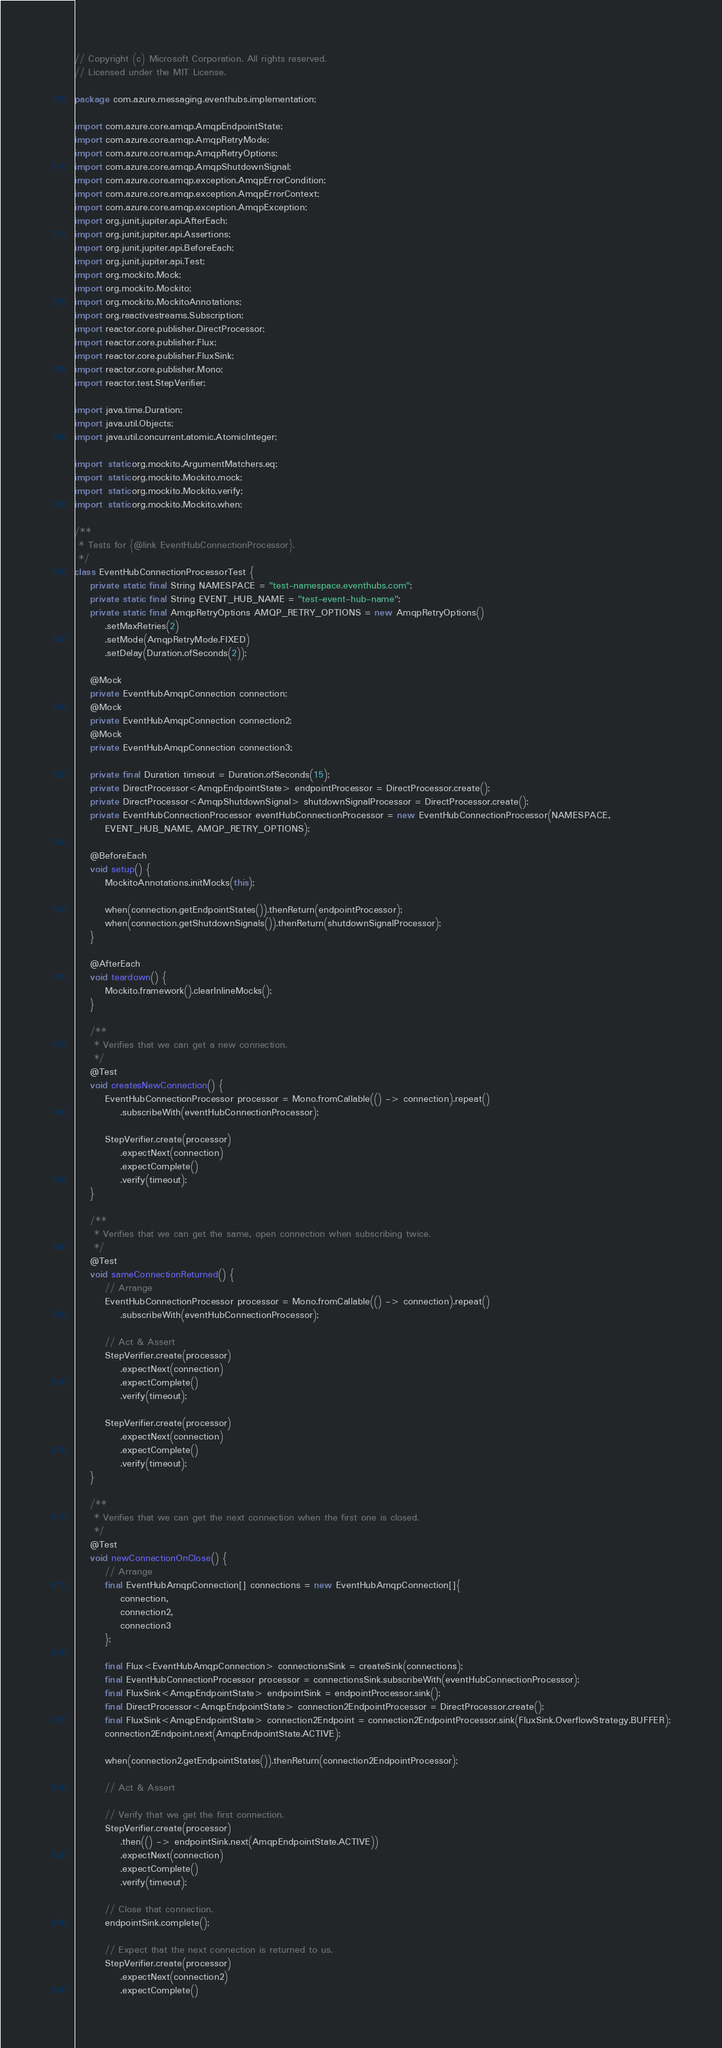<code> <loc_0><loc_0><loc_500><loc_500><_Java_>// Copyright (c) Microsoft Corporation. All rights reserved.
// Licensed under the MIT License.

package com.azure.messaging.eventhubs.implementation;

import com.azure.core.amqp.AmqpEndpointState;
import com.azure.core.amqp.AmqpRetryMode;
import com.azure.core.amqp.AmqpRetryOptions;
import com.azure.core.amqp.AmqpShutdownSignal;
import com.azure.core.amqp.exception.AmqpErrorCondition;
import com.azure.core.amqp.exception.AmqpErrorContext;
import com.azure.core.amqp.exception.AmqpException;
import org.junit.jupiter.api.AfterEach;
import org.junit.jupiter.api.Assertions;
import org.junit.jupiter.api.BeforeEach;
import org.junit.jupiter.api.Test;
import org.mockito.Mock;
import org.mockito.Mockito;
import org.mockito.MockitoAnnotations;
import org.reactivestreams.Subscription;
import reactor.core.publisher.DirectProcessor;
import reactor.core.publisher.Flux;
import reactor.core.publisher.FluxSink;
import reactor.core.publisher.Mono;
import reactor.test.StepVerifier;

import java.time.Duration;
import java.util.Objects;
import java.util.concurrent.atomic.AtomicInteger;

import static org.mockito.ArgumentMatchers.eq;
import static org.mockito.Mockito.mock;
import static org.mockito.Mockito.verify;
import static org.mockito.Mockito.when;

/**
 * Tests for {@link EventHubConnectionProcessor}.
 */
class EventHubConnectionProcessorTest {
    private static final String NAMESPACE = "test-namespace.eventhubs.com";
    private static final String EVENT_HUB_NAME = "test-event-hub-name";
    private static final AmqpRetryOptions AMQP_RETRY_OPTIONS = new AmqpRetryOptions()
        .setMaxRetries(2)
        .setMode(AmqpRetryMode.FIXED)
        .setDelay(Duration.ofSeconds(2));

    @Mock
    private EventHubAmqpConnection connection;
    @Mock
    private EventHubAmqpConnection connection2;
    @Mock
    private EventHubAmqpConnection connection3;

    private final Duration timeout = Duration.ofSeconds(15);
    private DirectProcessor<AmqpEndpointState> endpointProcessor = DirectProcessor.create();
    private DirectProcessor<AmqpShutdownSignal> shutdownSignalProcessor = DirectProcessor.create();
    private EventHubConnectionProcessor eventHubConnectionProcessor = new EventHubConnectionProcessor(NAMESPACE,
        EVENT_HUB_NAME, AMQP_RETRY_OPTIONS);

    @BeforeEach
    void setup() {
        MockitoAnnotations.initMocks(this);

        when(connection.getEndpointStates()).thenReturn(endpointProcessor);
        when(connection.getShutdownSignals()).thenReturn(shutdownSignalProcessor);
    }

    @AfterEach
    void teardown() {
        Mockito.framework().clearInlineMocks();
    }

    /**
     * Verifies that we can get a new connection.
     */
    @Test
    void createsNewConnection() {
        EventHubConnectionProcessor processor = Mono.fromCallable(() -> connection).repeat()
            .subscribeWith(eventHubConnectionProcessor);

        StepVerifier.create(processor)
            .expectNext(connection)
            .expectComplete()
            .verify(timeout);
    }

    /**
     * Verifies that we can get the same, open connection when subscribing twice.
     */
    @Test
    void sameConnectionReturned() {
        // Arrange
        EventHubConnectionProcessor processor = Mono.fromCallable(() -> connection).repeat()
            .subscribeWith(eventHubConnectionProcessor);

        // Act & Assert
        StepVerifier.create(processor)
            .expectNext(connection)
            .expectComplete()
            .verify(timeout);

        StepVerifier.create(processor)
            .expectNext(connection)
            .expectComplete()
            .verify(timeout);
    }

    /**
     * Verifies that we can get the next connection when the first one is closed.
     */
    @Test
    void newConnectionOnClose() {
        // Arrange
        final EventHubAmqpConnection[] connections = new EventHubAmqpConnection[]{
            connection,
            connection2,
            connection3
        };

        final Flux<EventHubAmqpConnection> connectionsSink = createSink(connections);
        final EventHubConnectionProcessor processor = connectionsSink.subscribeWith(eventHubConnectionProcessor);
        final FluxSink<AmqpEndpointState> endpointSink = endpointProcessor.sink();
        final DirectProcessor<AmqpEndpointState> connection2EndpointProcessor = DirectProcessor.create();
        final FluxSink<AmqpEndpointState> connection2Endpoint = connection2EndpointProcessor.sink(FluxSink.OverflowStrategy.BUFFER);
        connection2Endpoint.next(AmqpEndpointState.ACTIVE);

        when(connection2.getEndpointStates()).thenReturn(connection2EndpointProcessor);

        // Act & Assert

        // Verify that we get the first connection.
        StepVerifier.create(processor)
            .then(() -> endpointSink.next(AmqpEndpointState.ACTIVE))
            .expectNext(connection)
            .expectComplete()
            .verify(timeout);

        // Close that connection.
        endpointSink.complete();

        // Expect that the next connection is returned to us.
        StepVerifier.create(processor)
            .expectNext(connection2)
            .expectComplete()</code> 